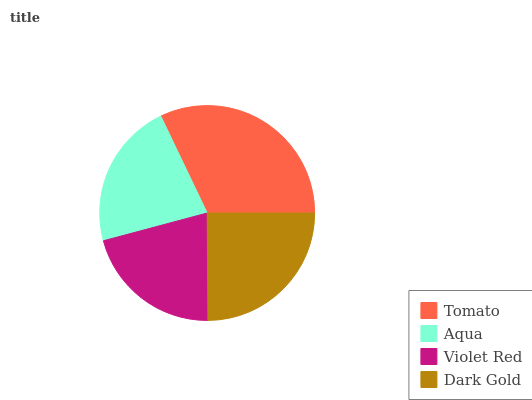Is Violet Red the minimum?
Answer yes or no. Yes. Is Tomato the maximum?
Answer yes or no. Yes. Is Aqua the minimum?
Answer yes or no. No. Is Aqua the maximum?
Answer yes or no. No. Is Tomato greater than Aqua?
Answer yes or no. Yes. Is Aqua less than Tomato?
Answer yes or no. Yes. Is Aqua greater than Tomato?
Answer yes or no. No. Is Tomato less than Aqua?
Answer yes or no. No. Is Dark Gold the high median?
Answer yes or no. Yes. Is Aqua the low median?
Answer yes or no. Yes. Is Aqua the high median?
Answer yes or no. No. Is Violet Red the low median?
Answer yes or no. No. 